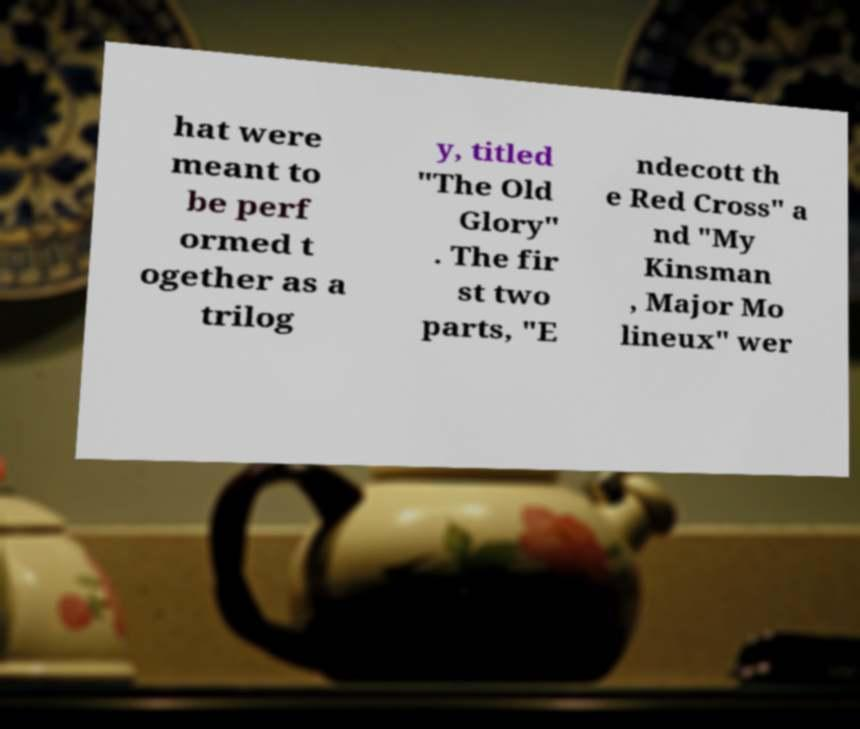What messages or text are displayed in this image? I need them in a readable, typed format. hat were meant to be perf ormed t ogether as a trilog y, titled "The Old Glory" . The fir st two parts, "E ndecott th e Red Cross" a nd "My Kinsman , Major Mo lineux" wer 